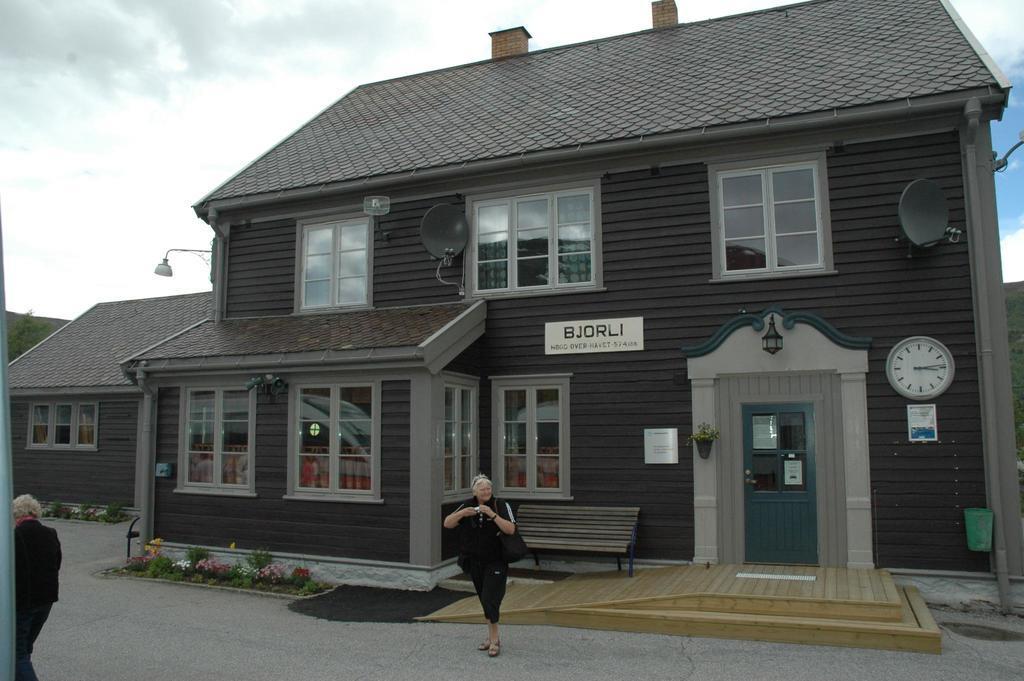Describe this image in one or two sentences. In this picture there is a building and there are boards and there is a clock and there is a plant on the wall and there is text on the boards. In the foreground there are two people walking and there are flowers and plants. At the top there is sky and there are clouds. At the bottom there is a road. At the back there are trees. 